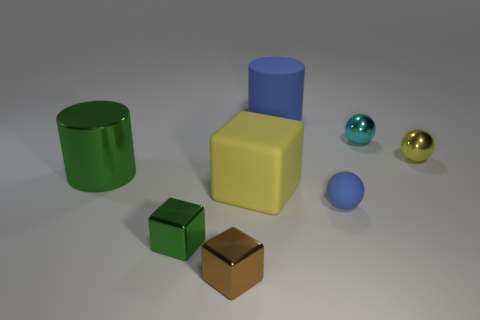Does the big metallic cylinder have the same color as the matte object behind the large green shiny cylinder?
Offer a very short reply. No. How many other objects are there of the same size as the blue rubber ball?
Make the answer very short. 4. The shiny thing that is the same color as the big rubber cube is what size?
Your answer should be very brief. Small. How many blocks are small green shiny things or small rubber objects?
Provide a succinct answer. 1. Does the small object that is left of the small brown cube have the same shape as the tiny brown object?
Ensure brevity in your answer.  Yes. Is the number of large blue rubber cylinders that are behind the shiny cylinder greater than the number of matte blocks?
Your answer should be compact. No. What is the color of the other block that is the same size as the brown block?
Provide a short and direct response. Green. How many things are either things that are to the left of the tiny green metal block or red matte balls?
Your response must be concise. 1. The big matte object that is the same color as the small matte sphere is what shape?
Your answer should be compact. Cylinder. What material is the tiny blue sphere right of the tiny brown block to the right of the tiny green shiny cube?
Your answer should be compact. Rubber. 